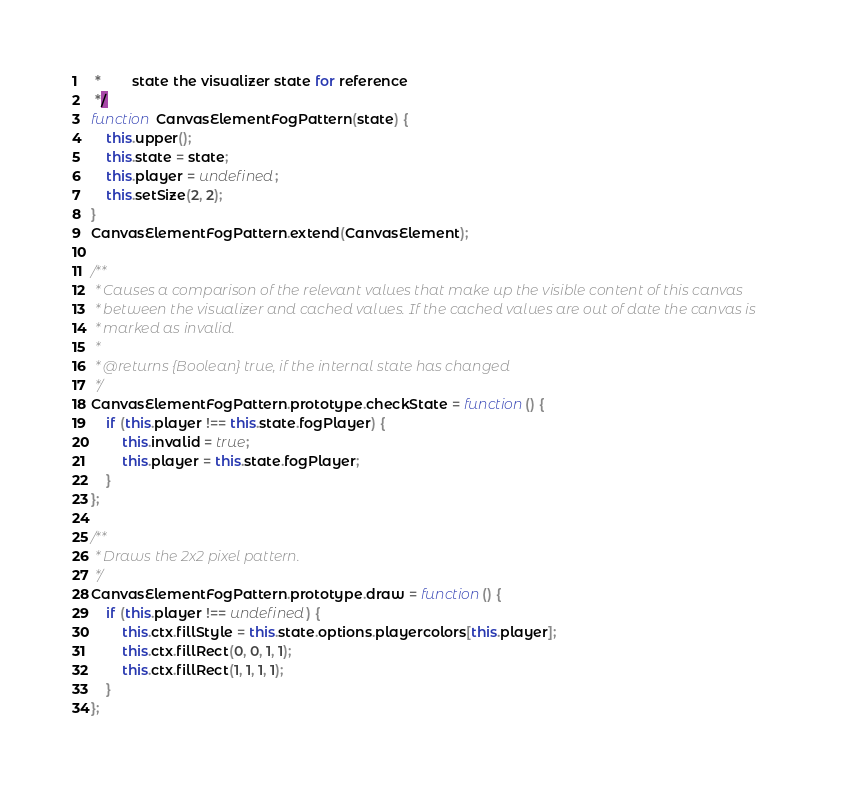Convert code to text. <code><loc_0><loc_0><loc_500><loc_500><_JavaScript_> *        state the visualizer state for reference
 */
function CanvasElementFogPattern(state) {
	this.upper();
	this.state = state;
	this.player = undefined;
	this.setSize(2, 2);
}
CanvasElementFogPattern.extend(CanvasElement);

/**
 * Causes a comparison of the relevant values that make up the visible content of this canvas
 * between the visualizer and cached values. If the cached values are out of date the canvas is
 * marked as invalid.
 *
 * @returns {Boolean} true, if the internal state has changed
 */
CanvasElementFogPattern.prototype.checkState = function() {
	if (this.player !== this.state.fogPlayer) {
		this.invalid = true;
		this.player = this.state.fogPlayer;
	}
};

/**
 * Draws the 2x2 pixel pattern.
 */
CanvasElementFogPattern.prototype.draw = function() {
	if (this.player !== undefined) {
		this.ctx.fillStyle = this.state.options.playercolors[this.player];
		this.ctx.fillRect(0, 0, 1, 1);
		this.ctx.fillRect(1, 1, 1, 1);
	}
};</code> 